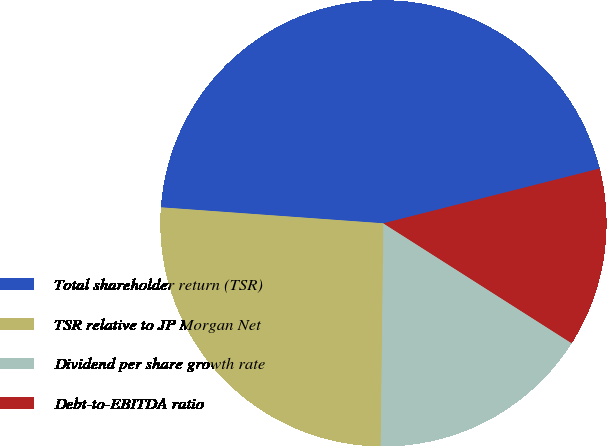Convert chart. <chart><loc_0><loc_0><loc_500><loc_500><pie_chart><fcel>Total shareholder return (TSR)<fcel>TSR relative to JP Morgan Net<fcel>Dividend per share growth rate<fcel>Debt-to-EBITDA ratio<nl><fcel>44.91%<fcel>25.95%<fcel>16.17%<fcel>12.97%<nl></chart> 